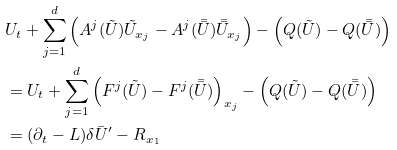<formula> <loc_0><loc_0><loc_500><loc_500>& U _ { t } + \sum _ { j = 1 } ^ { d } \left ( A ^ { j } ( \tilde { U } ) \tilde { U } _ { x _ { j } } - A ^ { j } ( \bar { \bar { U } } ) \bar { \bar { U } } _ { x _ { j } } \right ) - \left ( Q ( \tilde { U } ) - Q ( \bar { \bar { U } } ) \right ) \\ & = U _ { t } + \sum _ { j = 1 } ^ { d } \left ( F ^ { j } ( \tilde { U } ) - F ^ { j } ( \bar { \bar { U } } ) \right ) _ { x _ { j } } - \left ( Q ( \tilde { U } ) - Q ( \bar { \bar { U } } ) \right ) \\ & = ( \partial _ { t } - L ) \delta \bar { U } ^ { \prime } - R _ { x _ { 1 } }</formula> 